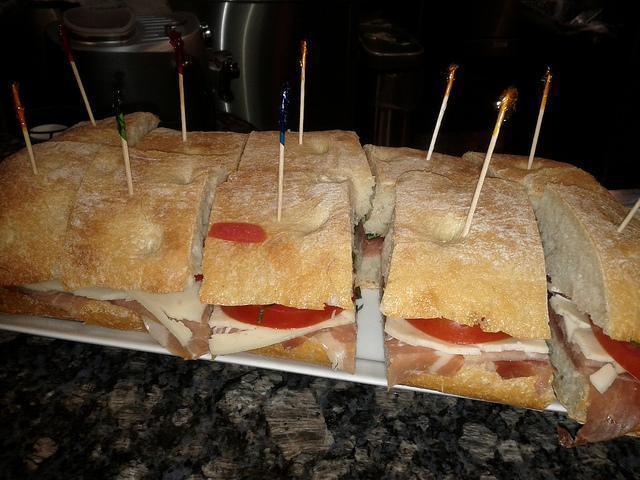What is being used to keep the sandwiches from falling apart?
From the following set of four choices, select the accurate answer to respond to the question.
Options: Tape, knives, toothpicks, glue. Toothpicks. 